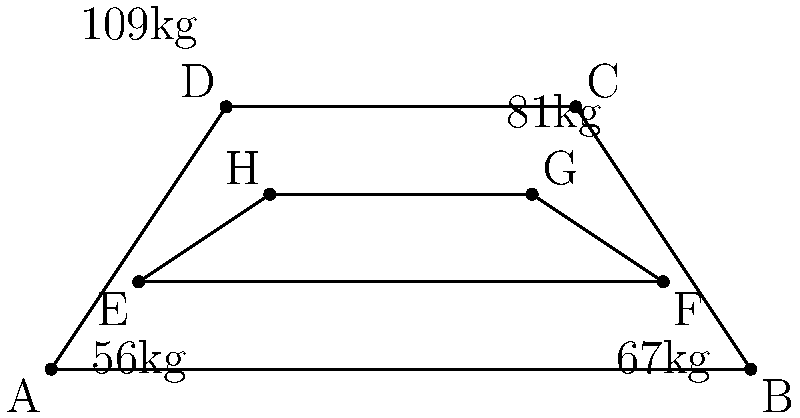In the Olympic weightlifting weight classes represented by congruent trapezoids ABCD and EFGH, if the ratio of area EFGH to area ABCD is 4:9, what is the ratio of EF to AB? Let's approach this step-by-step:

1) Since the trapezoids are congruent, they have the same height. Let's call this height $h$.

2) The area of a trapezoid is given by the formula: $A = \frac{1}{2}(b_1 + b_2)h$, where $b_1$ and $b_2$ are the parallel sides.

3) Let's say AB = $x$ and EF = $y$. Then, for trapezoid ABCD:
   $A_{ABCD} = \frac{1}{2}(x + DC)h$

4) For trapezoid EFGH:
   $A_{EFGH} = \frac{1}{2}(y + HG)h$

5) We're told that the ratio of areas is 4:9, so:
   $\frac{A_{EFGH}}{A_{ABCD}} = \frac{4}{9}$

6) Substituting the area formulas:
   $\frac{\frac{1}{2}(y + HG)h}{\frac{1}{2}(x + DC)h} = \frac{4}{9}$

7) The $\frac{1}{2}$ and $h$ cancel out, leaving:
   $\frac{y + HG}{x + DC} = \frac{4}{9}$

8) Since the trapezoids are congruent, the difference between their parallel sides is the same:
   $x - y = DC - HG$

9) Let this difference be $d$. Then $DC = y + d$ and $HG = x - d$

10) Substituting these into our equation:
    $\frac{y + (x - d)}{x + (y + d)} = \frac{4}{9}$

11) Simplifying: $\frac{x + y - d}{x + y + d} = \frac{4}{9}$

12) Cross multiplying: $9(x + y - d) = 4(x + y + d)$

13) Expanding: $9x + 9y - 9d = 4x + 4y + 4d$

14) Subtracting 4x and 4y from both sides: $5x + 5y - 9d = 4d$

15) Adding 9d to both sides: $5x + 5y = 13d$

16) Dividing by 5: $x + y = \frac{13}{5}d$

17) Remember, $x - y = d$. Adding this to our equation:
    $2x = \frac{18}{5}d$

18) Therefore, $x = \frac{9}{5}d$ and $y = \frac{4}{5}d$

19) The ratio of EF to AB is thus $y:x = 4:9$
Answer: 4:9 